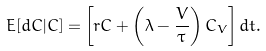<formula> <loc_0><loc_0><loc_500><loc_500>E [ d C | C ] = \left [ r C + \left ( \lambda - \frac { V } { \tau } \right ) C _ { V } \right ] d t .</formula> 